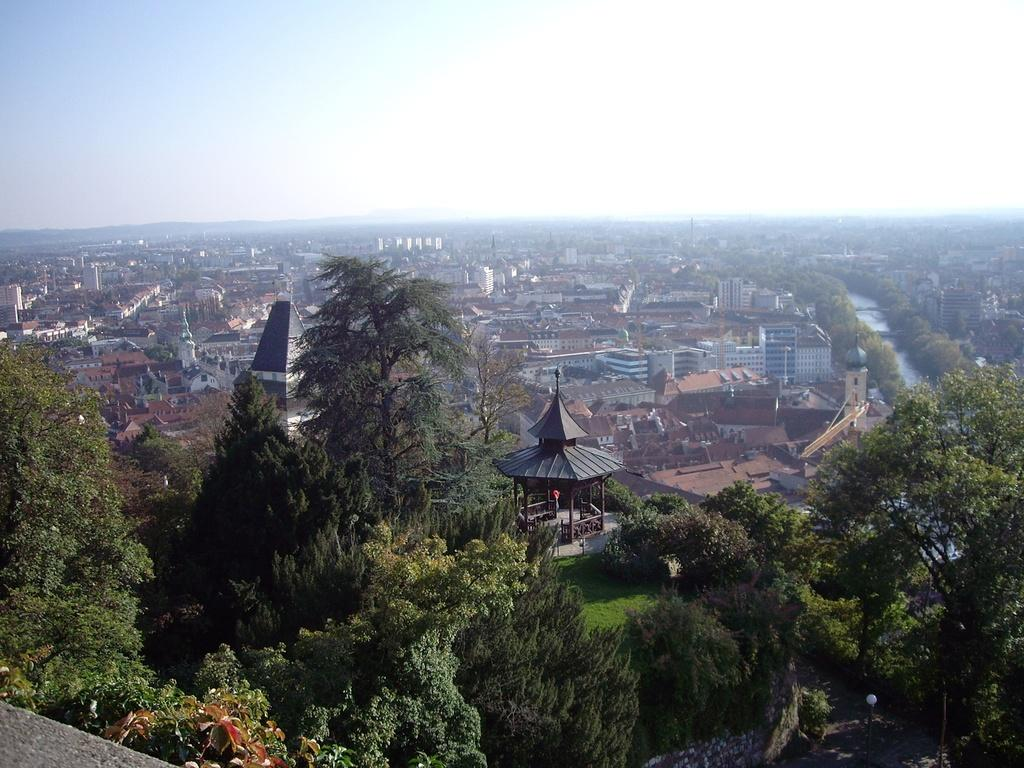What type of view is depicted in the image? The image appears to be an aerial view. What structures can be seen from this perspective? There are buildings visible in the image. What type of natural elements can be seen in the image? There are trees visible in the image. What else is visible in the image besides buildings and trees? The sky is visible in the image. What type of bone can be seen in the image? There is no bone present in the image. What type of land is visible in the image? The image does not specifically show land; it shows an aerial view of buildings, trees, and the sky. 